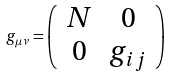<formula> <loc_0><loc_0><loc_500><loc_500>g _ { \mu \nu } = \left ( \begin{array} { c c } N & 0 \\ 0 & g _ { i j } \end{array} \right )</formula> 